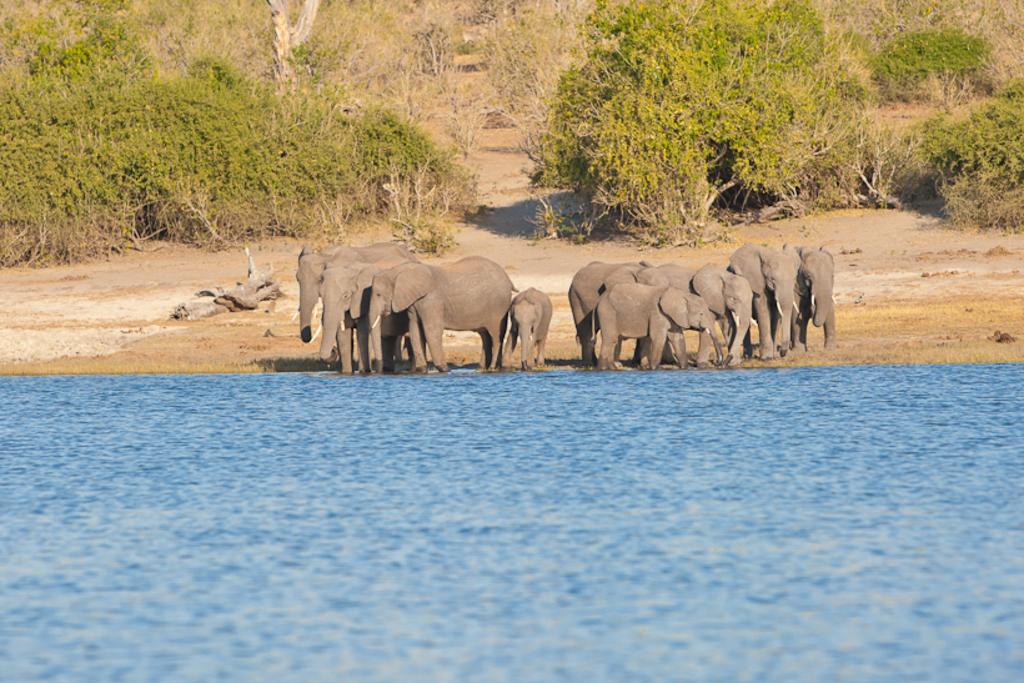What body of water is visible in the image? There is a lake in the image. What animals can be seen near the lake? There is a herd of elephants in the image. What type of vegetation is visible behind the elephants? There are trees behind the elephants in the image. What type of skate is being used by the elephants in the image? There are no skates present in the image; the elephants are not using any skates. What type of cap is being worn by the trees in the image? There are no caps present in the image; the trees are not wearing any caps. 